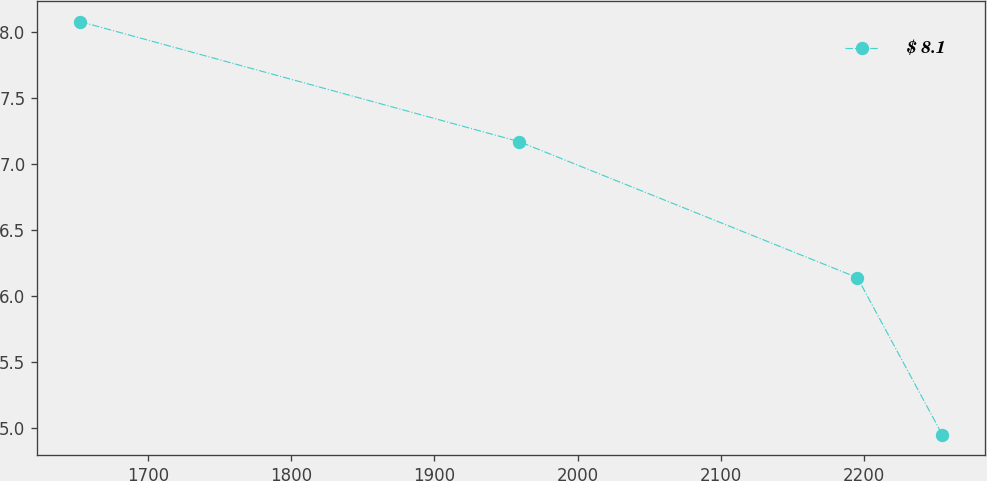Convert chart to OTSL. <chart><loc_0><loc_0><loc_500><loc_500><line_chart><ecel><fcel>$ 8.1<nl><fcel>1652.5<fcel>8.08<nl><fcel>1959.43<fcel>7.17<nl><fcel>2195.58<fcel>6.14<nl><fcel>2254.88<fcel>4.95<nl></chart> 